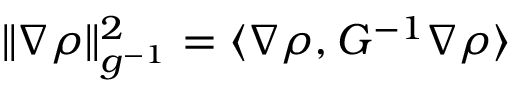Convert formula to latex. <formula><loc_0><loc_0><loc_500><loc_500>\| \nabla \rho \| _ { g ^ { - 1 } } ^ { 2 } = \langle \nabla \rho , G ^ { - 1 } \nabla \rho \rangle</formula> 